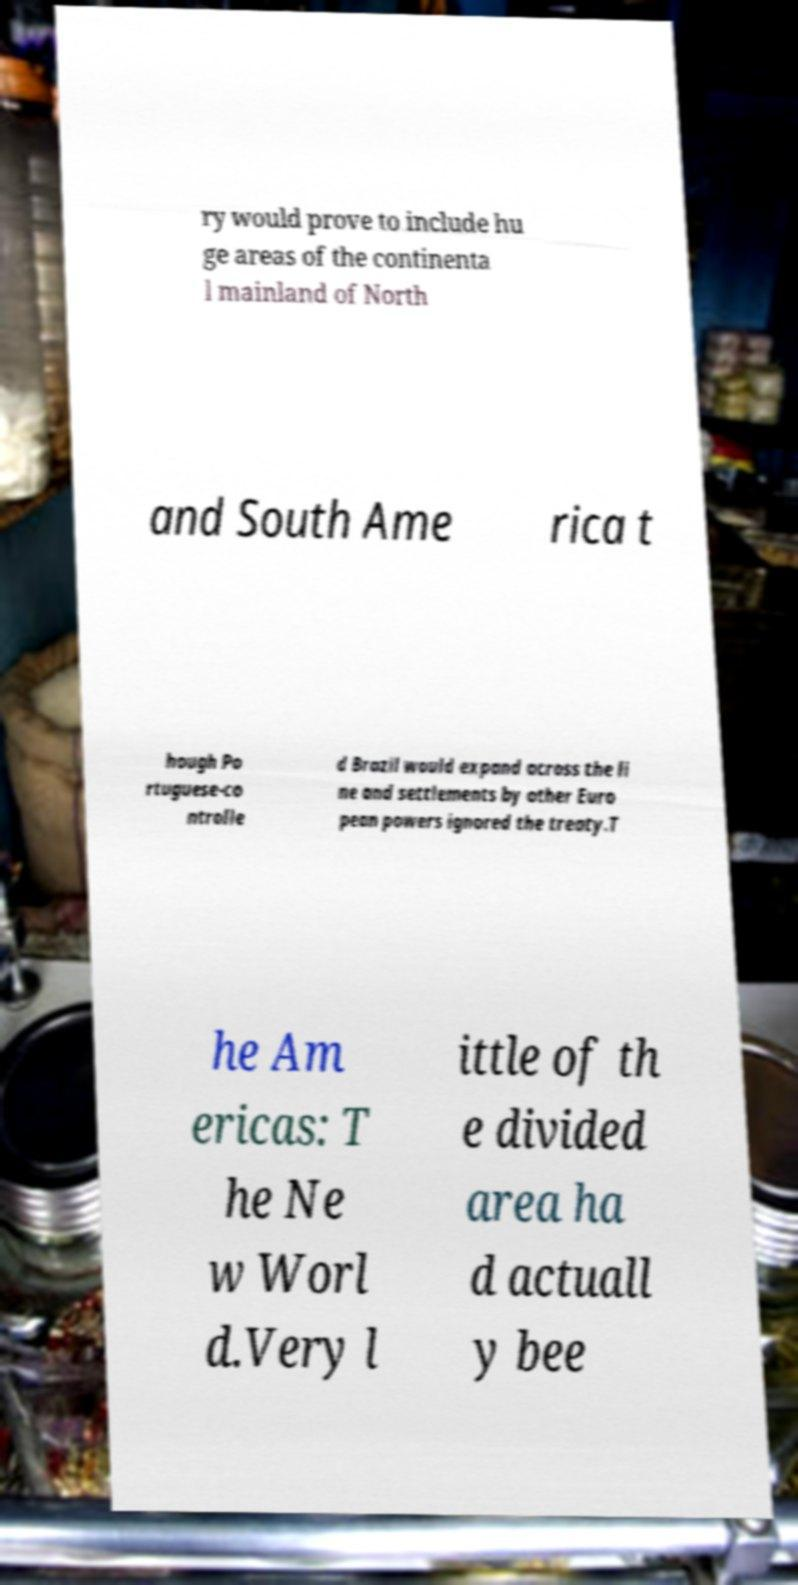Could you assist in decoding the text presented in this image and type it out clearly? ry would prove to include hu ge areas of the continenta l mainland of North and South Ame rica t hough Po rtuguese-co ntrolle d Brazil would expand across the li ne and settlements by other Euro pean powers ignored the treaty.T he Am ericas: T he Ne w Worl d.Very l ittle of th e divided area ha d actuall y bee 